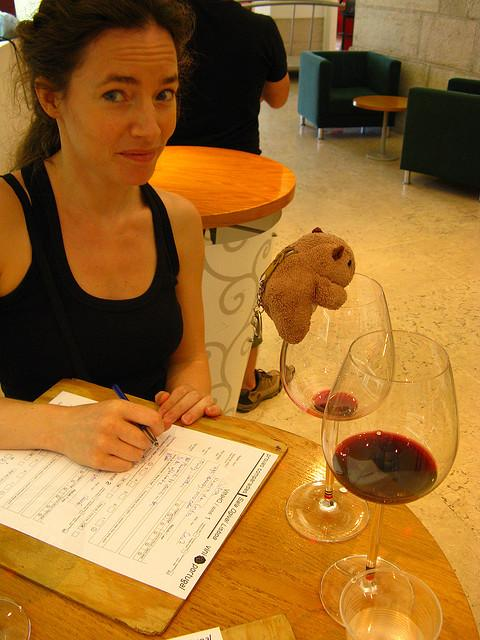What does it look like the stuffed animal is doing? Please explain your reasoning. drinking. The animal is on a glass with liquid in it. 